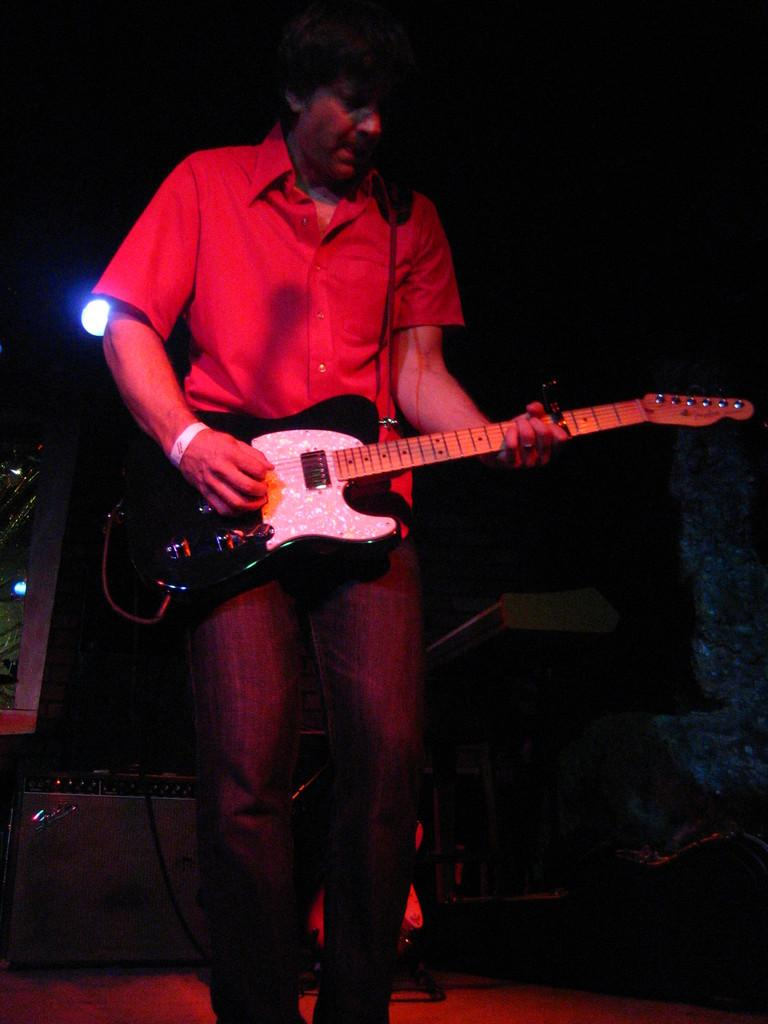What is the man in the image doing? The man is playing the guitar and singing on a mic. What instrument is the man holding in the image? The man is holding a guitar in the image. What can be seen in the background of the image? There are lights in the background of the image. How would you describe the lighting in the image? The setting is dark in the image. What type of crate is the man using to store his dad's answers in the image? A: There is no crate or mention of a dad or answers in the image. 